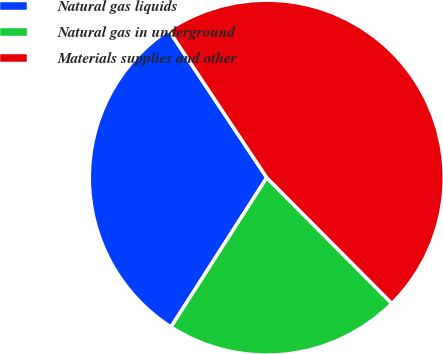<chart> <loc_0><loc_0><loc_500><loc_500><pie_chart><fcel>Natural gas liquids<fcel>Natural gas in underground<fcel>Materials supplies and other<nl><fcel>31.58%<fcel>21.53%<fcel>46.89%<nl></chart> 